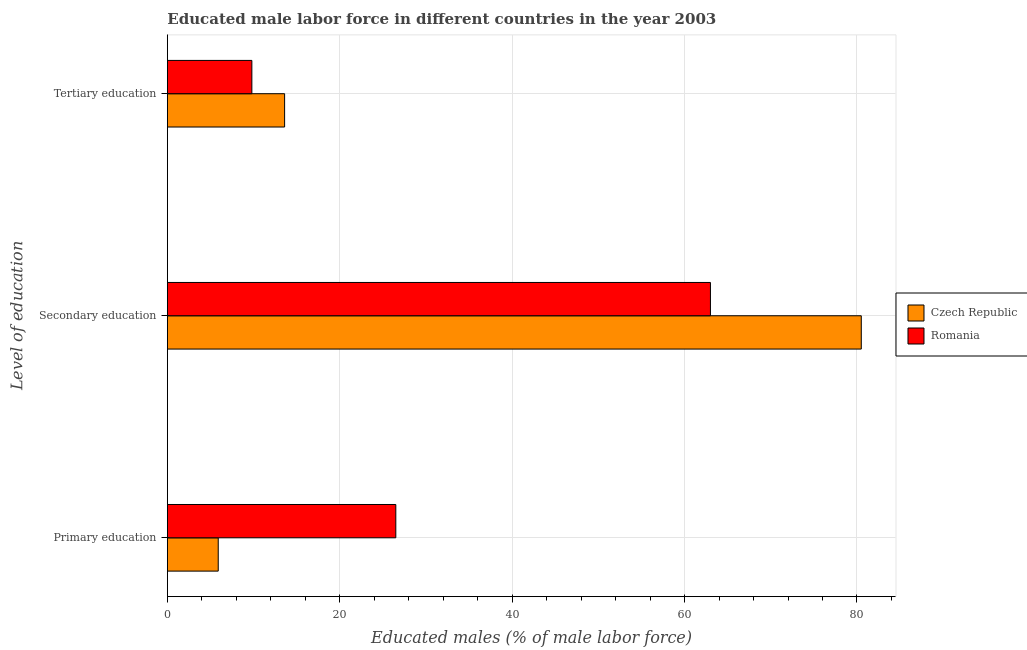How many different coloured bars are there?
Offer a terse response. 2. How many groups of bars are there?
Provide a short and direct response. 3. How many bars are there on the 1st tick from the top?
Ensure brevity in your answer.  2. What is the label of the 2nd group of bars from the top?
Your response must be concise. Secondary education. What is the percentage of male labor force who received tertiary education in Czech Republic?
Make the answer very short. 13.6. Across all countries, what is the maximum percentage of male labor force who received tertiary education?
Make the answer very short. 13.6. Across all countries, what is the minimum percentage of male labor force who received tertiary education?
Your answer should be compact. 9.8. In which country was the percentage of male labor force who received tertiary education maximum?
Your response must be concise. Czech Republic. In which country was the percentage of male labor force who received secondary education minimum?
Keep it short and to the point. Romania. What is the total percentage of male labor force who received primary education in the graph?
Give a very brief answer. 32.4. What is the difference between the percentage of male labor force who received secondary education in Romania and that in Czech Republic?
Keep it short and to the point. -17.5. What is the difference between the percentage of male labor force who received primary education in Romania and the percentage of male labor force who received secondary education in Czech Republic?
Your response must be concise. -54. What is the average percentage of male labor force who received tertiary education per country?
Provide a short and direct response. 11.7. What is the difference between the percentage of male labor force who received primary education and percentage of male labor force who received tertiary education in Romania?
Ensure brevity in your answer.  16.7. In how many countries, is the percentage of male labor force who received primary education greater than 28 %?
Offer a very short reply. 0. What is the ratio of the percentage of male labor force who received secondary education in Czech Republic to that in Romania?
Your answer should be very brief. 1.28. Is the percentage of male labor force who received secondary education in Romania less than that in Czech Republic?
Your response must be concise. Yes. Is the difference between the percentage of male labor force who received primary education in Romania and Czech Republic greater than the difference between the percentage of male labor force who received secondary education in Romania and Czech Republic?
Provide a succinct answer. Yes. What is the difference between the highest and the second highest percentage of male labor force who received primary education?
Your answer should be compact. 20.6. What is the difference between the highest and the lowest percentage of male labor force who received tertiary education?
Ensure brevity in your answer.  3.8. What does the 1st bar from the top in Secondary education represents?
Your answer should be very brief. Romania. What does the 2nd bar from the bottom in Tertiary education represents?
Your response must be concise. Romania. How many bars are there?
Make the answer very short. 6. Are all the bars in the graph horizontal?
Offer a very short reply. Yes. Does the graph contain any zero values?
Your response must be concise. No. How many legend labels are there?
Your answer should be very brief. 2. How are the legend labels stacked?
Keep it short and to the point. Vertical. What is the title of the graph?
Provide a short and direct response. Educated male labor force in different countries in the year 2003. What is the label or title of the X-axis?
Provide a short and direct response. Educated males (% of male labor force). What is the label or title of the Y-axis?
Offer a terse response. Level of education. What is the Educated males (% of male labor force) in Czech Republic in Primary education?
Provide a short and direct response. 5.9. What is the Educated males (% of male labor force) in Romania in Primary education?
Your response must be concise. 26.5. What is the Educated males (% of male labor force) of Czech Republic in Secondary education?
Your answer should be very brief. 80.5. What is the Educated males (% of male labor force) of Czech Republic in Tertiary education?
Provide a succinct answer. 13.6. What is the Educated males (% of male labor force) of Romania in Tertiary education?
Make the answer very short. 9.8. Across all Level of education, what is the maximum Educated males (% of male labor force) of Czech Republic?
Your response must be concise. 80.5. Across all Level of education, what is the minimum Educated males (% of male labor force) of Czech Republic?
Make the answer very short. 5.9. Across all Level of education, what is the minimum Educated males (% of male labor force) in Romania?
Offer a terse response. 9.8. What is the total Educated males (% of male labor force) of Romania in the graph?
Your response must be concise. 99.3. What is the difference between the Educated males (% of male labor force) in Czech Republic in Primary education and that in Secondary education?
Provide a short and direct response. -74.6. What is the difference between the Educated males (% of male labor force) in Romania in Primary education and that in Secondary education?
Your response must be concise. -36.5. What is the difference between the Educated males (% of male labor force) of Czech Republic in Primary education and that in Tertiary education?
Provide a short and direct response. -7.7. What is the difference between the Educated males (% of male labor force) of Romania in Primary education and that in Tertiary education?
Offer a very short reply. 16.7. What is the difference between the Educated males (% of male labor force) of Czech Republic in Secondary education and that in Tertiary education?
Ensure brevity in your answer.  66.9. What is the difference between the Educated males (% of male labor force) of Romania in Secondary education and that in Tertiary education?
Your response must be concise. 53.2. What is the difference between the Educated males (% of male labor force) in Czech Republic in Primary education and the Educated males (% of male labor force) in Romania in Secondary education?
Make the answer very short. -57.1. What is the difference between the Educated males (% of male labor force) in Czech Republic in Primary education and the Educated males (% of male labor force) in Romania in Tertiary education?
Provide a succinct answer. -3.9. What is the difference between the Educated males (% of male labor force) in Czech Republic in Secondary education and the Educated males (% of male labor force) in Romania in Tertiary education?
Your answer should be very brief. 70.7. What is the average Educated males (% of male labor force) in Czech Republic per Level of education?
Your answer should be compact. 33.33. What is the average Educated males (% of male labor force) in Romania per Level of education?
Provide a short and direct response. 33.1. What is the difference between the Educated males (% of male labor force) of Czech Republic and Educated males (% of male labor force) of Romania in Primary education?
Ensure brevity in your answer.  -20.6. What is the difference between the Educated males (% of male labor force) in Czech Republic and Educated males (% of male labor force) in Romania in Tertiary education?
Provide a short and direct response. 3.8. What is the ratio of the Educated males (% of male labor force) in Czech Republic in Primary education to that in Secondary education?
Make the answer very short. 0.07. What is the ratio of the Educated males (% of male labor force) of Romania in Primary education to that in Secondary education?
Offer a terse response. 0.42. What is the ratio of the Educated males (% of male labor force) in Czech Republic in Primary education to that in Tertiary education?
Provide a succinct answer. 0.43. What is the ratio of the Educated males (% of male labor force) of Romania in Primary education to that in Tertiary education?
Give a very brief answer. 2.7. What is the ratio of the Educated males (% of male labor force) in Czech Republic in Secondary education to that in Tertiary education?
Your answer should be very brief. 5.92. What is the ratio of the Educated males (% of male labor force) in Romania in Secondary education to that in Tertiary education?
Make the answer very short. 6.43. What is the difference between the highest and the second highest Educated males (% of male labor force) of Czech Republic?
Offer a very short reply. 66.9. What is the difference between the highest and the second highest Educated males (% of male labor force) of Romania?
Your answer should be very brief. 36.5. What is the difference between the highest and the lowest Educated males (% of male labor force) in Czech Republic?
Provide a succinct answer. 74.6. What is the difference between the highest and the lowest Educated males (% of male labor force) of Romania?
Give a very brief answer. 53.2. 